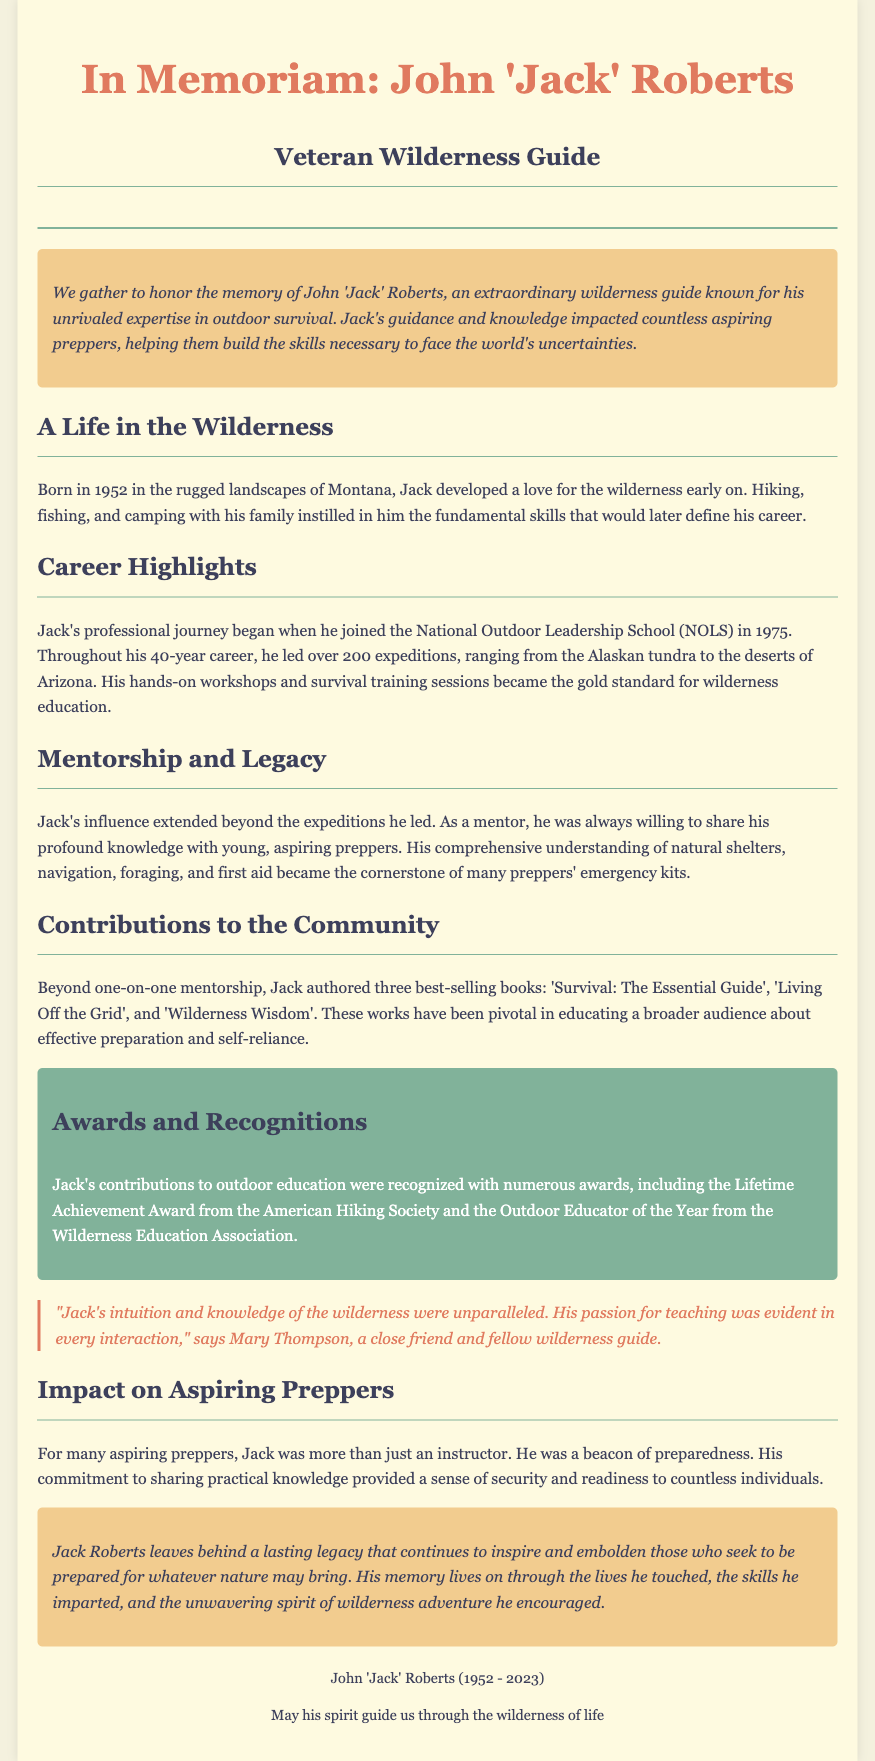What year was John 'Jack' Roberts born? The document states that Jack was born in 1952.
Answer: 1952 How many expeditions did Jack lead during his career? The obituary mentions he led over 200 expeditions.
Answer: over 200 What is one of Jack's best-selling books? The document lists several books, among them 'Survival: The Essential Guide'.
Answer: 'Survival: The Essential Guide' What award did Jack receive from the American Hiking Society? The document states he received the Lifetime Achievement Award from this organization.
Answer: Lifetime Achievement Award What skill area did Jack's mentorship primarily focus on? The document highlights that his mentorship focused on outdoor survival skills.
Answer: outdoor survival skills What was Jack's profession? The obituary describes Jack as a wilderness guide.
Answer: wilderness guide In which state was Jack born? The document indicates that he was born in Montana.
Answer: Montana Who described Jack's passion for teaching? The document attributes the quote about Jack's passion to Mary Thompson.
Answer: Mary Thompson What legacy did Jack leave behind? The obituary emphasizes that he left a lasting legacy that inspires aspiring preppers.
Answer: lasting legacy 